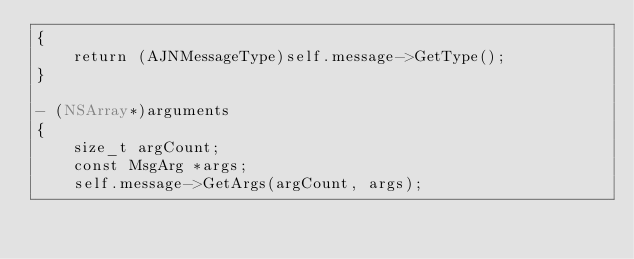Convert code to text. <code><loc_0><loc_0><loc_500><loc_500><_ObjectiveC_>{
    return (AJNMessageType)self.message->GetType();
}

- (NSArray*)arguments
{
    size_t argCount;
    const MsgArg *args;
    self.message->GetArgs(argCount, args);</code> 